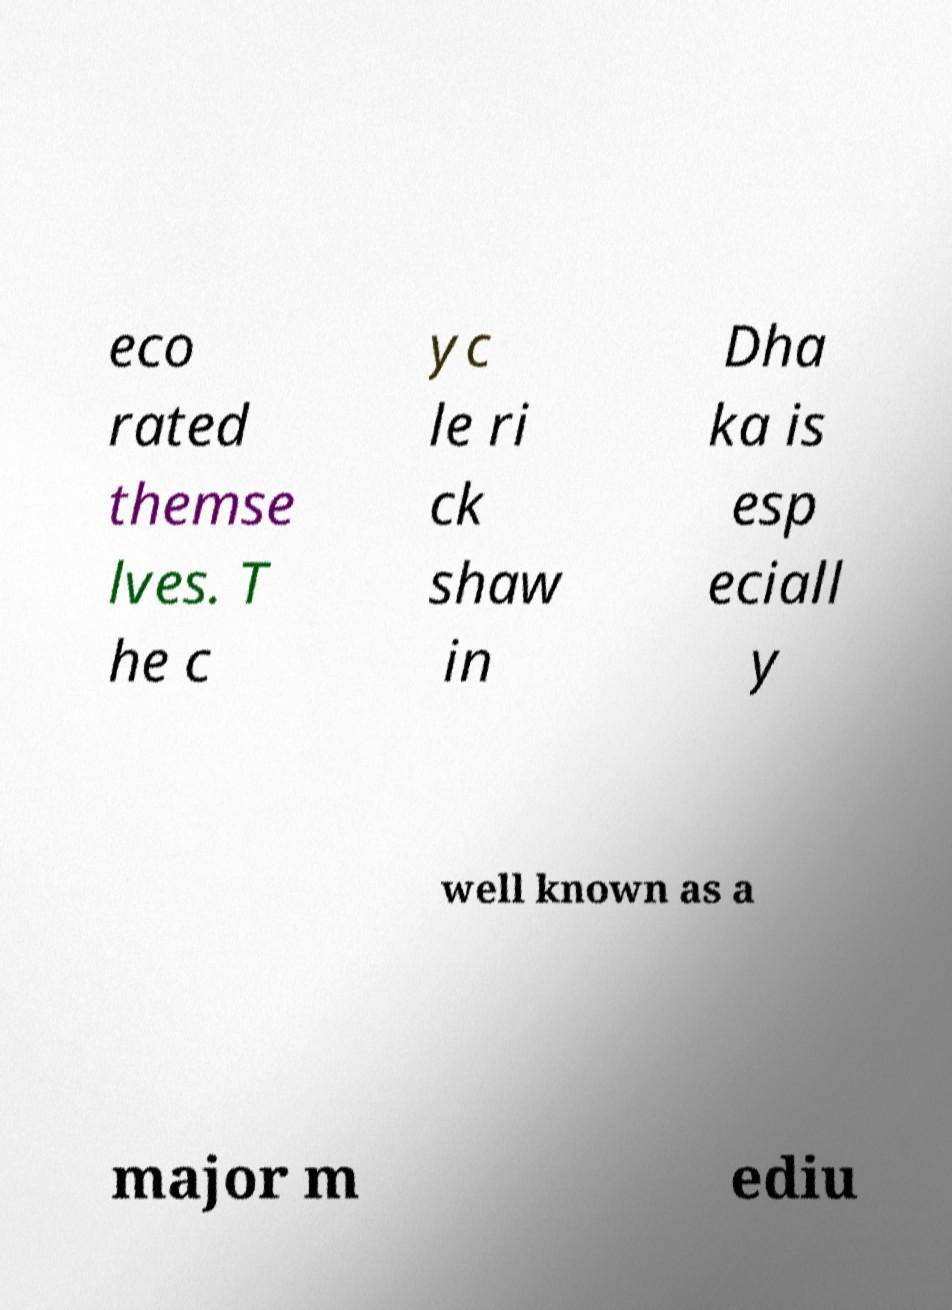I need the written content from this picture converted into text. Can you do that? eco rated themse lves. T he c yc le ri ck shaw in Dha ka is esp eciall y well known as a major m ediu 